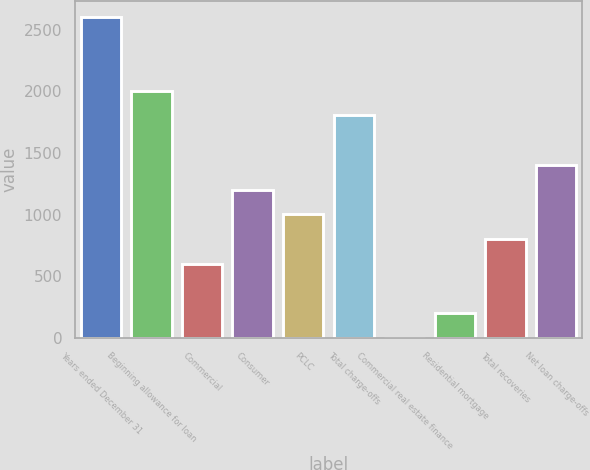Convert chart to OTSL. <chart><loc_0><loc_0><loc_500><loc_500><bar_chart><fcel>Years ended December 31<fcel>Beginning allowance for loan<fcel>Commercial<fcel>Consumer<fcel>PCLC<fcel>Total charge-offs<fcel>Commercial real estate finance<fcel>Residential mortgage<fcel>Total recoveries<fcel>Net loan charge-offs<nl><fcel>2606.47<fcel>2005<fcel>601.57<fcel>1203.04<fcel>1002.55<fcel>1804.51<fcel>0.1<fcel>200.59<fcel>802.06<fcel>1403.53<nl></chart> 